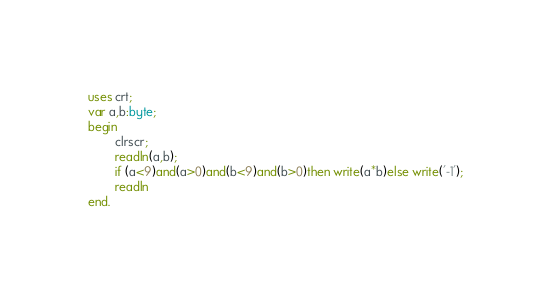<code> <loc_0><loc_0><loc_500><loc_500><_Pascal_>uses crt;
var a,b:byte;
begin
        clrscr;
        readln(a,b);
        if (a<9)and(a>0)and(b<9)and(b>0)then write(a*b)else write('-1');
        readln
end.
</code> 